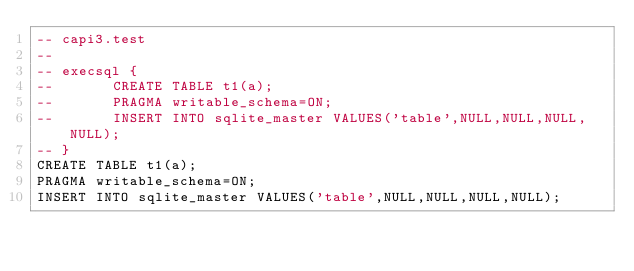<code> <loc_0><loc_0><loc_500><loc_500><_SQL_>-- capi3.test
-- 
-- execsql {
--       CREATE TABLE t1(a);
--       PRAGMA writable_schema=ON;
--       INSERT INTO sqlite_master VALUES('table',NULL,NULL,NULL,NULL);
-- }
CREATE TABLE t1(a);
PRAGMA writable_schema=ON;
INSERT INTO sqlite_master VALUES('table',NULL,NULL,NULL,NULL);</code> 